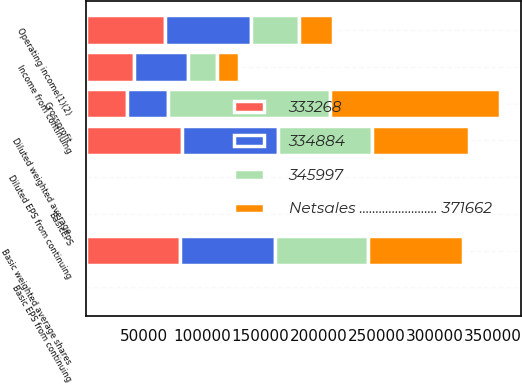Convert chart. <chart><loc_0><loc_0><loc_500><loc_500><stacked_bar_chart><ecel><fcel>Grossprofit<fcel>Operating income(1)(2)<fcel>Income from continuing<fcel>Basic EPS from continuing<fcel>BasicEPS<fcel>Diluted EPS from continuing<fcel>Basic weighted average shares<fcel>Diluted weighted average<nl><fcel>333268<fcel>35262.5<fcel>68099<fcel>41379<fcel>0.51<fcel>0.51<fcel>0.5<fcel>81067<fcel>82288<nl><fcel>334884<fcel>35262.5<fcel>73808<fcel>46054<fcel>0.57<fcel>0.57<fcel>0.56<fcel>81322<fcel>82746<nl><fcel>Netsales ........................ 371662<fcel>146397<fcel>29417<fcel>19075<fcel>0.23<fcel>0.23<fcel>0.23<fcel>81572<fcel>82957<nl><fcel>345997<fcel>139137<fcel>41108<fcel>24852<fcel>0.31<fcel>0.31<fcel>0.31<fcel>80529<fcel>81289<nl></chart> 